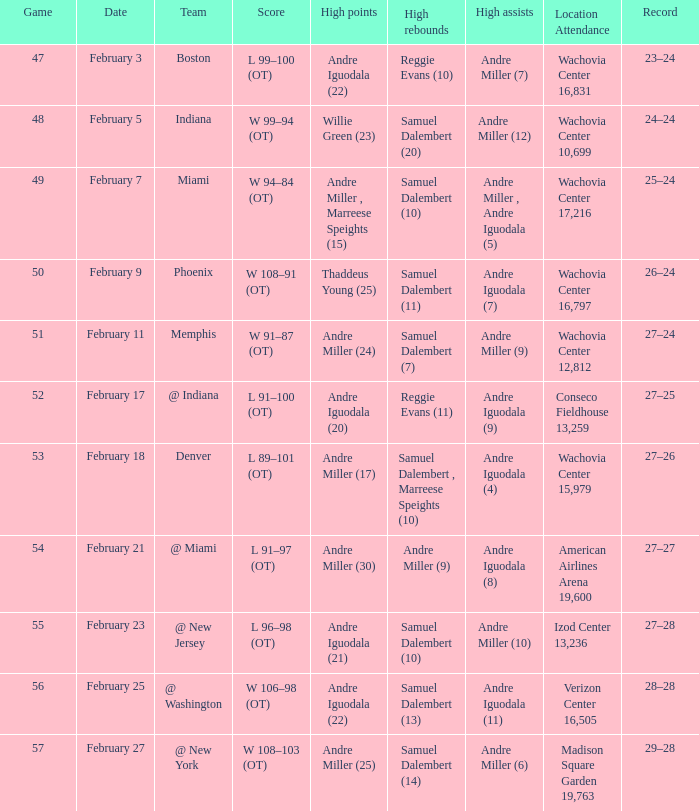When did they play Miami? February 7. 